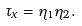<formula> <loc_0><loc_0><loc_500><loc_500>\tau _ { x } = \eta _ { 1 } \eta _ { 2 } .</formula> 